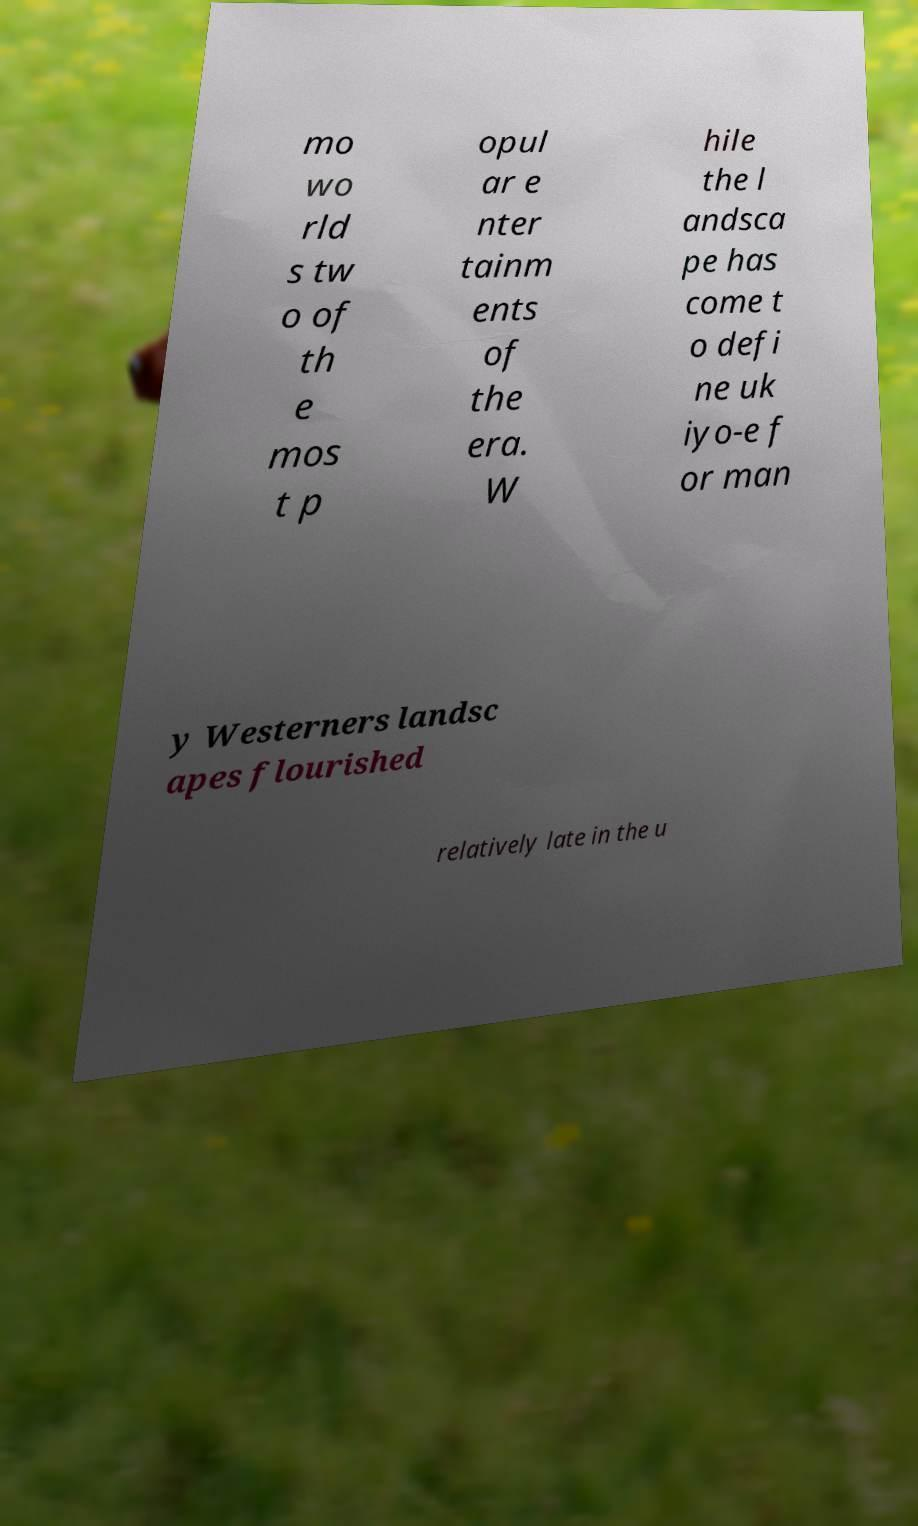Could you assist in decoding the text presented in this image and type it out clearly? mo wo rld s tw o of th e mos t p opul ar e nter tainm ents of the era. W hile the l andsca pe has come t o defi ne uk iyo-e f or man y Westerners landsc apes flourished relatively late in the u 